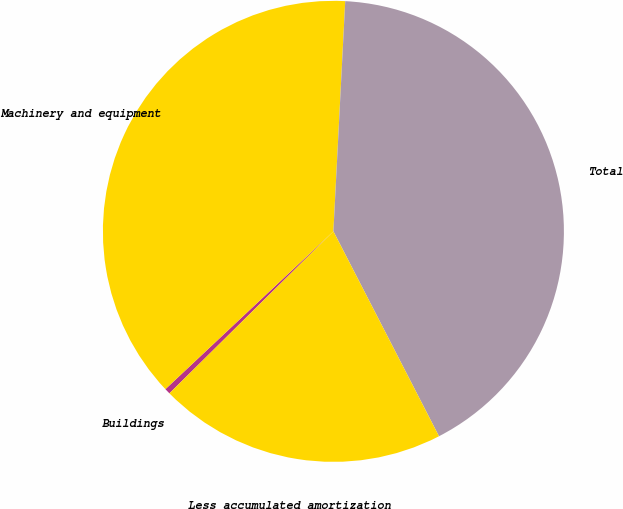Convert chart. <chart><loc_0><loc_0><loc_500><loc_500><pie_chart><fcel>Buildings<fcel>Machinery and equipment<fcel>Total<fcel>Less accumulated amortization<nl><fcel>0.4%<fcel>37.82%<fcel>41.61%<fcel>20.17%<nl></chart> 